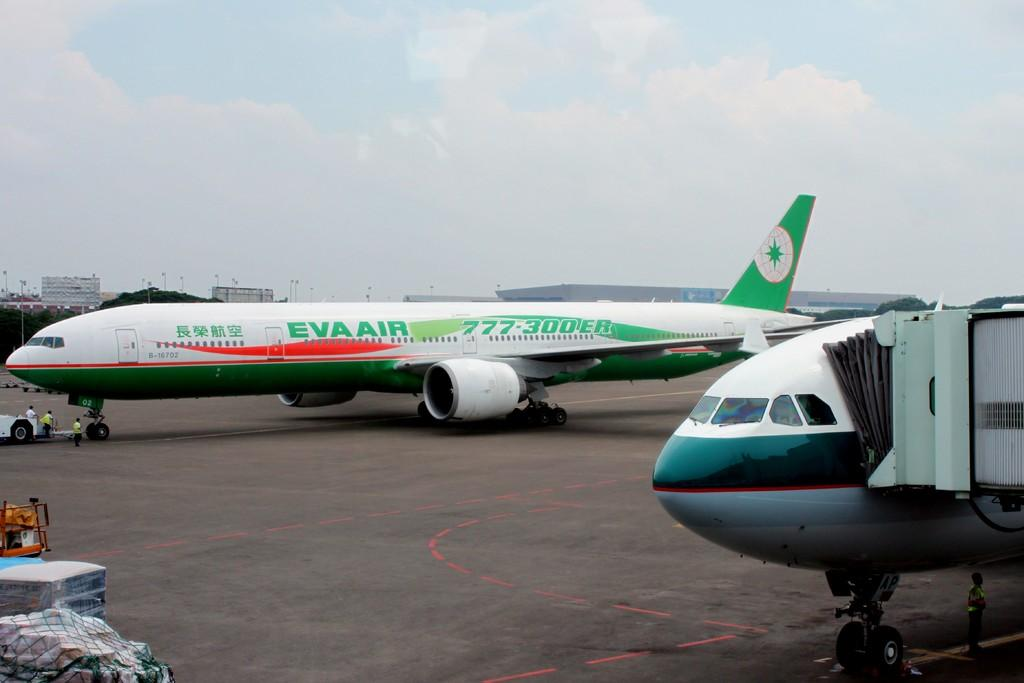<image>
Summarize the visual content of the image. A tarmac with two planes on it, one of them with the name, "Eva Air". 